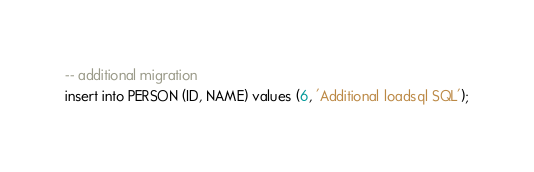Convert code to text. <code><loc_0><loc_0><loc_500><loc_500><_SQL_>-- additional migration
insert into PERSON (ID, NAME) values (6, 'Additional loadsql SQL');</code> 